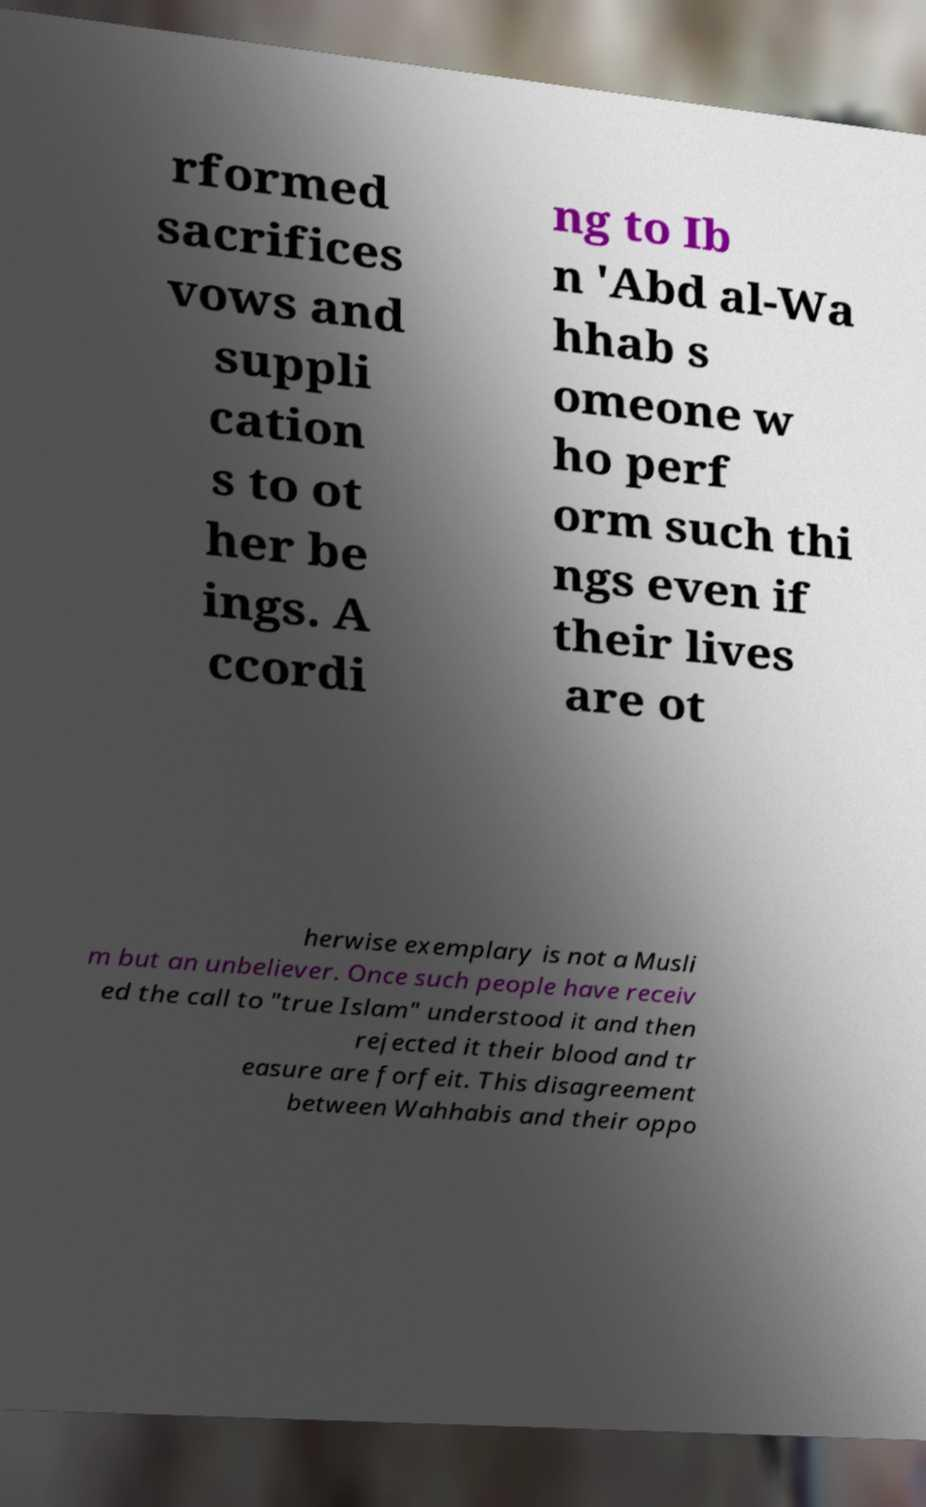I need the written content from this picture converted into text. Can you do that? rformed sacrifices vows and suppli cation s to ot her be ings. A ccordi ng to Ib n 'Abd al-Wa hhab s omeone w ho perf orm such thi ngs even if their lives are ot herwise exemplary is not a Musli m but an unbeliever. Once such people have receiv ed the call to "true Islam" understood it and then rejected it their blood and tr easure are forfeit. This disagreement between Wahhabis and their oppo 